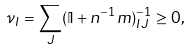<formula> <loc_0><loc_0><loc_500><loc_500>\nu _ { I } = \sum _ { J } ( \mathbb { I } + n ^ { - 1 } m ) ^ { - 1 } _ { I J } \geq 0 ,</formula> 